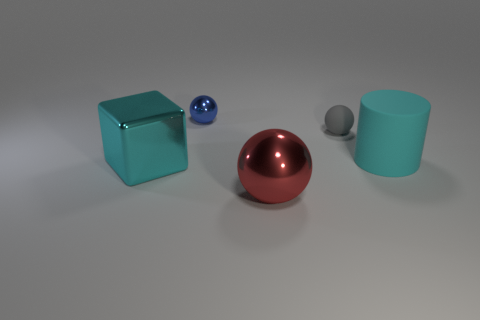Add 4 large green cylinders. How many objects exist? 9 Subtract all cylinders. How many objects are left? 4 Add 4 tiny green rubber balls. How many tiny green rubber balls exist? 4 Subtract 0 yellow cylinders. How many objects are left? 5 Subtract all big red objects. Subtract all tiny gray objects. How many objects are left? 3 Add 4 large balls. How many large balls are left? 5 